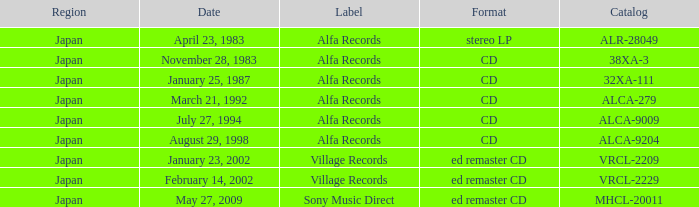What is the format of the date February 14, 2002? Ed remaster cd. 